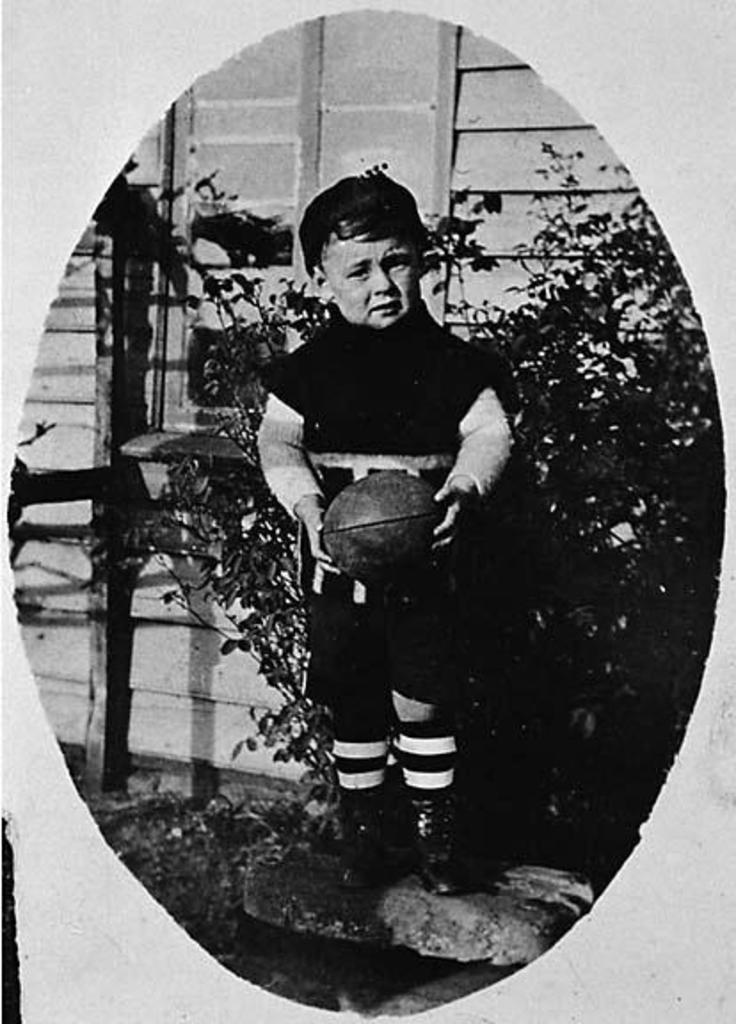What is the main object in the image? There is a frame in the image. Who or what is inside the frame? A boy is standing in the frame. What is the boy holding in the image? The boy is holding a ball. What can be seen behind the boy in the image? There are plants and a wall visible behind the boy. How much value does the hose have in the image? There is no hose present in the image, so it does not have any value in the context of the image. 